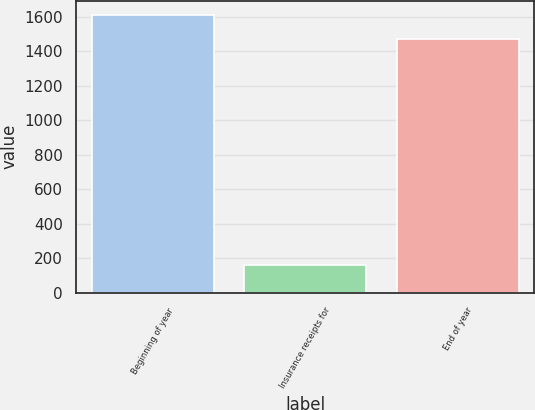Convert chart to OTSL. <chart><loc_0><loc_0><loc_500><loc_500><bar_chart><fcel>Beginning of year<fcel>Insurance receipts for<fcel>End of year<nl><fcel>1613.2<fcel>160<fcel>1473<nl></chart> 